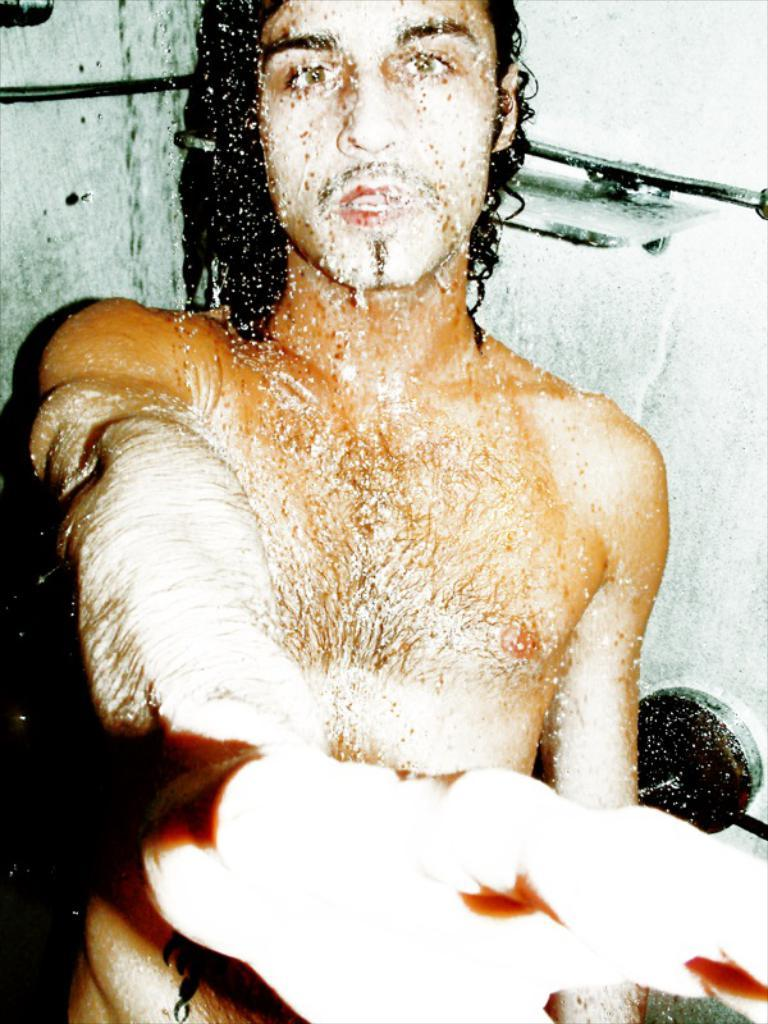Who or what is present in the image? There is a person in the image. What can be seen in the background of the image? There is a door, a door handle, and a soap dish in the background of the image. How many clocks are visible in the image? There are no clocks visible in the image. What type of sea creature can be seen swimming in the background of the image? There is no sea creature present in the image; it features a person and objects in a background setting. 